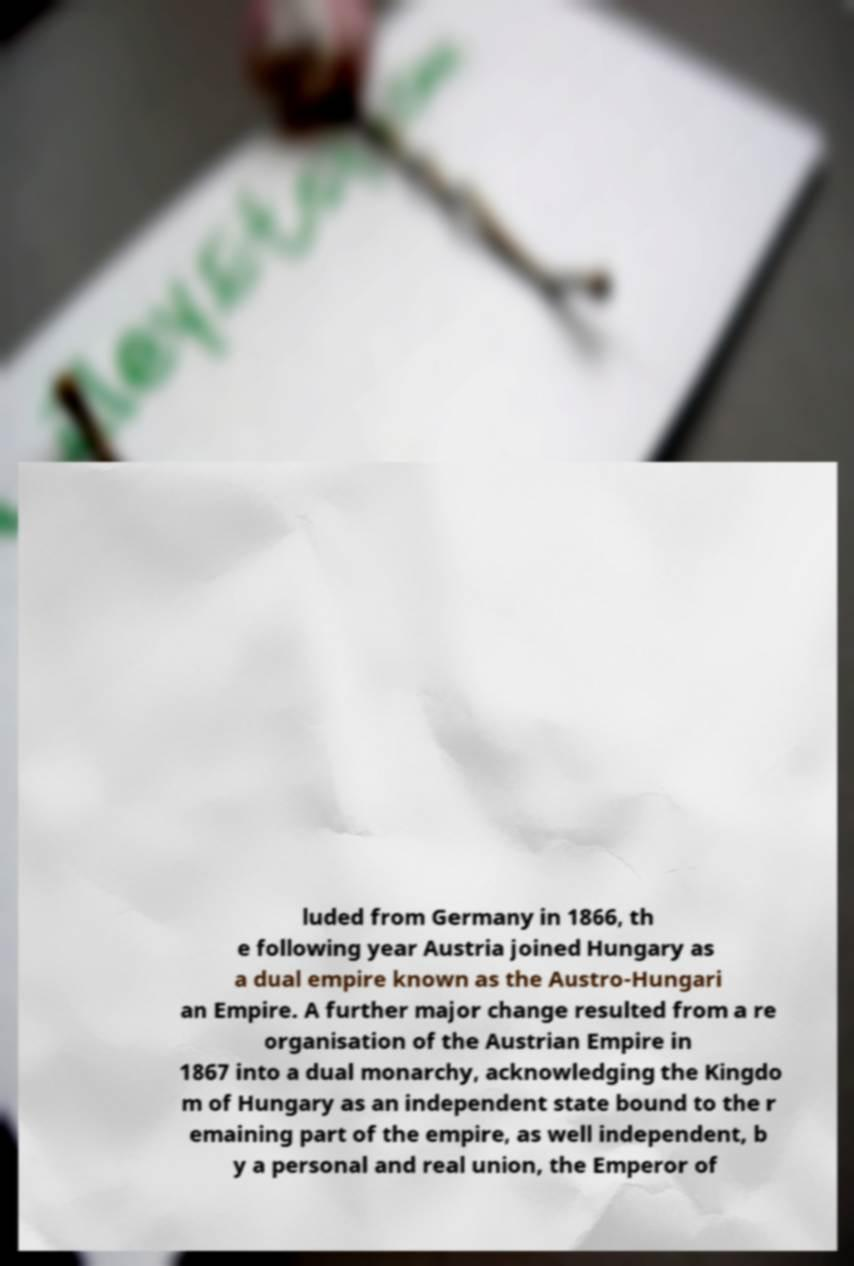Please identify and transcribe the text found in this image. luded from Germany in 1866, th e following year Austria joined Hungary as a dual empire known as the Austro-Hungari an Empire. A further major change resulted from a re organisation of the Austrian Empire in 1867 into a dual monarchy, acknowledging the Kingdo m of Hungary as an independent state bound to the r emaining part of the empire, as well independent, b y a personal and real union, the Emperor of 